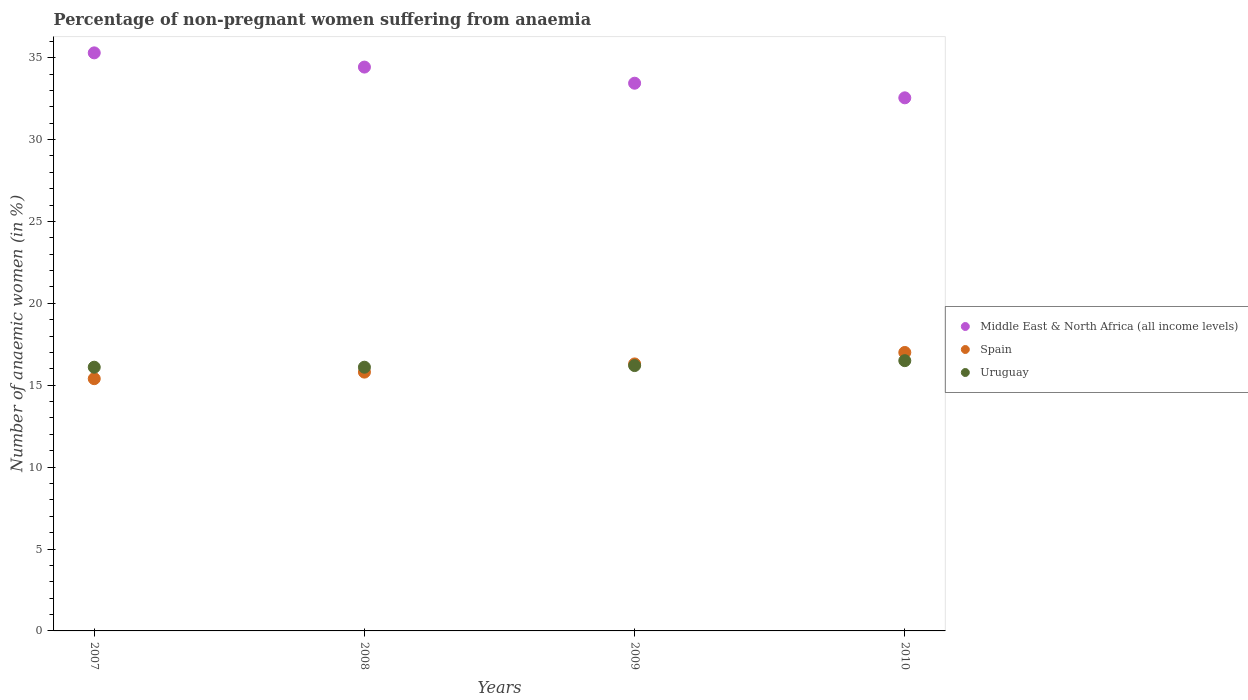Is the number of dotlines equal to the number of legend labels?
Provide a short and direct response. Yes. Across all years, what is the maximum percentage of non-pregnant women suffering from anaemia in Middle East & North Africa (all income levels)?
Make the answer very short. 35.29. In which year was the percentage of non-pregnant women suffering from anaemia in Uruguay minimum?
Provide a succinct answer. 2007. What is the total percentage of non-pregnant women suffering from anaemia in Spain in the graph?
Make the answer very short. 64.5. What is the difference between the percentage of non-pregnant women suffering from anaemia in Middle East & North Africa (all income levels) in 2009 and that in 2010?
Provide a short and direct response. 0.89. What is the difference between the percentage of non-pregnant women suffering from anaemia in Uruguay in 2009 and the percentage of non-pregnant women suffering from anaemia in Spain in 2010?
Your answer should be compact. -0.8. What is the average percentage of non-pregnant women suffering from anaemia in Spain per year?
Your response must be concise. 16.12. In the year 2007, what is the difference between the percentage of non-pregnant women suffering from anaemia in Uruguay and percentage of non-pregnant women suffering from anaemia in Middle East & North Africa (all income levels)?
Your response must be concise. -19.19. In how many years, is the percentage of non-pregnant women suffering from anaemia in Middle East & North Africa (all income levels) greater than 2 %?
Make the answer very short. 4. What is the ratio of the percentage of non-pregnant women suffering from anaemia in Spain in 2009 to that in 2010?
Keep it short and to the point. 0.96. Is the percentage of non-pregnant women suffering from anaemia in Uruguay in 2009 less than that in 2010?
Your response must be concise. Yes. What is the difference between the highest and the second highest percentage of non-pregnant women suffering from anaemia in Spain?
Your answer should be compact. 0.7. What is the difference between the highest and the lowest percentage of non-pregnant women suffering from anaemia in Uruguay?
Your response must be concise. 0.4. Is the sum of the percentage of non-pregnant women suffering from anaemia in Middle East & North Africa (all income levels) in 2008 and 2009 greater than the maximum percentage of non-pregnant women suffering from anaemia in Spain across all years?
Provide a short and direct response. Yes. Does the percentage of non-pregnant women suffering from anaemia in Uruguay monotonically increase over the years?
Provide a succinct answer. No. Is the percentage of non-pregnant women suffering from anaemia in Spain strictly greater than the percentage of non-pregnant women suffering from anaemia in Uruguay over the years?
Offer a terse response. No. Is the percentage of non-pregnant women suffering from anaemia in Spain strictly less than the percentage of non-pregnant women suffering from anaemia in Uruguay over the years?
Make the answer very short. No. How many years are there in the graph?
Give a very brief answer. 4. What is the difference between two consecutive major ticks on the Y-axis?
Give a very brief answer. 5. What is the title of the graph?
Offer a terse response. Percentage of non-pregnant women suffering from anaemia. What is the label or title of the Y-axis?
Give a very brief answer. Number of anaemic women (in %). What is the Number of anaemic women (in %) in Middle East & North Africa (all income levels) in 2007?
Offer a terse response. 35.29. What is the Number of anaemic women (in %) of Spain in 2007?
Offer a terse response. 15.4. What is the Number of anaemic women (in %) of Uruguay in 2007?
Make the answer very short. 16.1. What is the Number of anaemic women (in %) of Middle East & North Africa (all income levels) in 2008?
Your answer should be very brief. 34.42. What is the Number of anaemic women (in %) in Uruguay in 2008?
Offer a terse response. 16.1. What is the Number of anaemic women (in %) of Middle East & North Africa (all income levels) in 2009?
Your answer should be compact. 33.44. What is the Number of anaemic women (in %) of Uruguay in 2009?
Offer a very short reply. 16.2. What is the Number of anaemic women (in %) in Middle East & North Africa (all income levels) in 2010?
Provide a short and direct response. 32.55. What is the Number of anaemic women (in %) in Spain in 2010?
Provide a succinct answer. 17. Across all years, what is the maximum Number of anaemic women (in %) of Middle East & North Africa (all income levels)?
Ensure brevity in your answer.  35.29. Across all years, what is the maximum Number of anaemic women (in %) of Spain?
Make the answer very short. 17. Across all years, what is the minimum Number of anaemic women (in %) in Middle East & North Africa (all income levels)?
Ensure brevity in your answer.  32.55. Across all years, what is the minimum Number of anaemic women (in %) of Spain?
Your response must be concise. 15.4. Across all years, what is the minimum Number of anaemic women (in %) in Uruguay?
Provide a succinct answer. 16.1. What is the total Number of anaemic women (in %) in Middle East & North Africa (all income levels) in the graph?
Your response must be concise. 135.7. What is the total Number of anaemic women (in %) of Spain in the graph?
Give a very brief answer. 64.5. What is the total Number of anaemic women (in %) in Uruguay in the graph?
Offer a very short reply. 64.9. What is the difference between the Number of anaemic women (in %) in Middle East & North Africa (all income levels) in 2007 and that in 2008?
Your answer should be compact. 0.87. What is the difference between the Number of anaemic women (in %) of Spain in 2007 and that in 2008?
Keep it short and to the point. -0.4. What is the difference between the Number of anaemic women (in %) of Middle East & North Africa (all income levels) in 2007 and that in 2009?
Your response must be concise. 1.85. What is the difference between the Number of anaemic women (in %) of Spain in 2007 and that in 2009?
Provide a succinct answer. -0.9. What is the difference between the Number of anaemic women (in %) in Middle East & North Africa (all income levels) in 2007 and that in 2010?
Ensure brevity in your answer.  2.75. What is the difference between the Number of anaemic women (in %) in Spain in 2007 and that in 2010?
Give a very brief answer. -1.6. What is the difference between the Number of anaemic women (in %) of Uruguay in 2008 and that in 2009?
Provide a short and direct response. -0.1. What is the difference between the Number of anaemic women (in %) in Middle East & North Africa (all income levels) in 2008 and that in 2010?
Keep it short and to the point. 1.88. What is the difference between the Number of anaemic women (in %) of Uruguay in 2008 and that in 2010?
Provide a short and direct response. -0.4. What is the difference between the Number of anaemic women (in %) of Middle East & North Africa (all income levels) in 2009 and that in 2010?
Provide a short and direct response. 0.89. What is the difference between the Number of anaemic women (in %) of Uruguay in 2009 and that in 2010?
Keep it short and to the point. -0.3. What is the difference between the Number of anaemic women (in %) in Middle East & North Africa (all income levels) in 2007 and the Number of anaemic women (in %) in Spain in 2008?
Make the answer very short. 19.49. What is the difference between the Number of anaemic women (in %) in Middle East & North Africa (all income levels) in 2007 and the Number of anaemic women (in %) in Uruguay in 2008?
Your answer should be compact. 19.19. What is the difference between the Number of anaemic women (in %) in Spain in 2007 and the Number of anaemic women (in %) in Uruguay in 2008?
Ensure brevity in your answer.  -0.7. What is the difference between the Number of anaemic women (in %) of Middle East & North Africa (all income levels) in 2007 and the Number of anaemic women (in %) of Spain in 2009?
Provide a succinct answer. 18.99. What is the difference between the Number of anaemic women (in %) in Middle East & North Africa (all income levels) in 2007 and the Number of anaemic women (in %) in Uruguay in 2009?
Provide a succinct answer. 19.09. What is the difference between the Number of anaemic women (in %) in Spain in 2007 and the Number of anaemic women (in %) in Uruguay in 2009?
Your answer should be compact. -0.8. What is the difference between the Number of anaemic women (in %) of Middle East & North Africa (all income levels) in 2007 and the Number of anaemic women (in %) of Spain in 2010?
Keep it short and to the point. 18.29. What is the difference between the Number of anaemic women (in %) of Middle East & North Africa (all income levels) in 2007 and the Number of anaemic women (in %) of Uruguay in 2010?
Provide a succinct answer. 18.79. What is the difference between the Number of anaemic women (in %) in Middle East & North Africa (all income levels) in 2008 and the Number of anaemic women (in %) in Spain in 2009?
Offer a terse response. 18.12. What is the difference between the Number of anaemic women (in %) of Middle East & North Africa (all income levels) in 2008 and the Number of anaemic women (in %) of Uruguay in 2009?
Keep it short and to the point. 18.22. What is the difference between the Number of anaemic women (in %) in Spain in 2008 and the Number of anaemic women (in %) in Uruguay in 2009?
Ensure brevity in your answer.  -0.4. What is the difference between the Number of anaemic women (in %) of Middle East & North Africa (all income levels) in 2008 and the Number of anaemic women (in %) of Spain in 2010?
Offer a terse response. 17.42. What is the difference between the Number of anaemic women (in %) of Middle East & North Africa (all income levels) in 2008 and the Number of anaemic women (in %) of Uruguay in 2010?
Make the answer very short. 17.92. What is the difference between the Number of anaemic women (in %) in Middle East & North Africa (all income levels) in 2009 and the Number of anaemic women (in %) in Spain in 2010?
Your answer should be very brief. 16.44. What is the difference between the Number of anaemic women (in %) of Middle East & North Africa (all income levels) in 2009 and the Number of anaemic women (in %) of Uruguay in 2010?
Give a very brief answer. 16.94. What is the difference between the Number of anaemic women (in %) in Spain in 2009 and the Number of anaemic women (in %) in Uruguay in 2010?
Keep it short and to the point. -0.2. What is the average Number of anaemic women (in %) in Middle East & North Africa (all income levels) per year?
Offer a terse response. 33.92. What is the average Number of anaemic women (in %) of Spain per year?
Make the answer very short. 16.12. What is the average Number of anaemic women (in %) in Uruguay per year?
Offer a very short reply. 16.23. In the year 2007, what is the difference between the Number of anaemic women (in %) in Middle East & North Africa (all income levels) and Number of anaemic women (in %) in Spain?
Your answer should be compact. 19.89. In the year 2007, what is the difference between the Number of anaemic women (in %) of Middle East & North Africa (all income levels) and Number of anaemic women (in %) of Uruguay?
Provide a succinct answer. 19.19. In the year 2007, what is the difference between the Number of anaemic women (in %) in Spain and Number of anaemic women (in %) in Uruguay?
Your answer should be very brief. -0.7. In the year 2008, what is the difference between the Number of anaemic women (in %) of Middle East & North Africa (all income levels) and Number of anaemic women (in %) of Spain?
Provide a succinct answer. 18.62. In the year 2008, what is the difference between the Number of anaemic women (in %) of Middle East & North Africa (all income levels) and Number of anaemic women (in %) of Uruguay?
Your answer should be very brief. 18.32. In the year 2009, what is the difference between the Number of anaemic women (in %) of Middle East & North Africa (all income levels) and Number of anaemic women (in %) of Spain?
Offer a terse response. 17.14. In the year 2009, what is the difference between the Number of anaemic women (in %) of Middle East & North Africa (all income levels) and Number of anaemic women (in %) of Uruguay?
Provide a succinct answer. 17.24. In the year 2010, what is the difference between the Number of anaemic women (in %) in Middle East & North Africa (all income levels) and Number of anaemic women (in %) in Spain?
Make the answer very short. 15.55. In the year 2010, what is the difference between the Number of anaemic women (in %) of Middle East & North Africa (all income levels) and Number of anaemic women (in %) of Uruguay?
Ensure brevity in your answer.  16.05. In the year 2010, what is the difference between the Number of anaemic women (in %) of Spain and Number of anaemic women (in %) of Uruguay?
Your answer should be compact. 0.5. What is the ratio of the Number of anaemic women (in %) of Middle East & North Africa (all income levels) in 2007 to that in 2008?
Give a very brief answer. 1.03. What is the ratio of the Number of anaemic women (in %) in Spain in 2007 to that in 2008?
Your answer should be compact. 0.97. What is the ratio of the Number of anaemic women (in %) of Uruguay in 2007 to that in 2008?
Make the answer very short. 1. What is the ratio of the Number of anaemic women (in %) in Middle East & North Africa (all income levels) in 2007 to that in 2009?
Provide a short and direct response. 1.06. What is the ratio of the Number of anaemic women (in %) of Spain in 2007 to that in 2009?
Offer a very short reply. 0.94. What is the ratio of the Number of anaemic women (in %) in Middle East & North Africa (all income levels) in 2007 to that in 2010?
Provide a short and direct response. 1.08. What is the ratio of the Number of anaemic women (in %) of Spain in 2007 to that in 2010?
Offer a very short reply. 0.91. What is the ratio of the Number of anaemic women (in %) in Uruguay in 2007 to that in 2010?
Offer a terse response. 0.98. What is the ratio of the Number of anaemic women (in %) in Middle East & North Africa (all income levels) in 2008 to that in 2009?
Your answer should be very brief. 1.03. What is the ratio of the Number of anaemic women (in %) in Spain in 2008 to that in 2009?
Give a very brief answer. 0.97. What is the ratio of the Number of anaemic women (in %) in Uruguay in 2008 to that in 2009?
Offer a very short reply. 0.99. What is the ratio of the Number of anaemic women (in %) in Middle East & North Africa (all income levels) in 2008 to that in 2010?
Make the answer very short. 1.06. What is the ratio of the Number of anaemic women (in %) of Spain in 2008 to that in 2010?
Offer a very short reply. 0.93. What is the ratio of the Number of anaemic women (in %) in Uruguay in 2008 to that in 2010?
Keep it short and to the point. 0.98. What is the ratio of the Number of anaemic women (in %) in Middle East & North Africa (all income levels) in 2009 to that in 2010?
Provide a succinct answer. 1.03. What is the ratio of the Number of anaemic women (in %) of Spain in 2009 to that in 2010?
Your answer should be very brief. 0.96. What is the ratio of the Number of anaemic women (in %) of Uruguay in 2009 to that in 2010?
Keep it short and to the point. 0.98. What is the difference between the highest and the second highest Number of anaemic women (in %) of Middle East & North Africa (all income levels)?
Your answer should be very brief. 0.87. What is the difference between the highest and the second highest Number of anaemic women (in %) of Spain?
Keep it short and to the point. 0.7. What is the difference between the highest and the lowest Number of anaemic women (in %) in Middle East & North Africa (all income levels)?
Ensure brevity in your answer.  2.75. What is the difference between the highest and the lowest Number of anaemic women (in %) in Uruguay?
Provide a short and direct response. 0.4. 